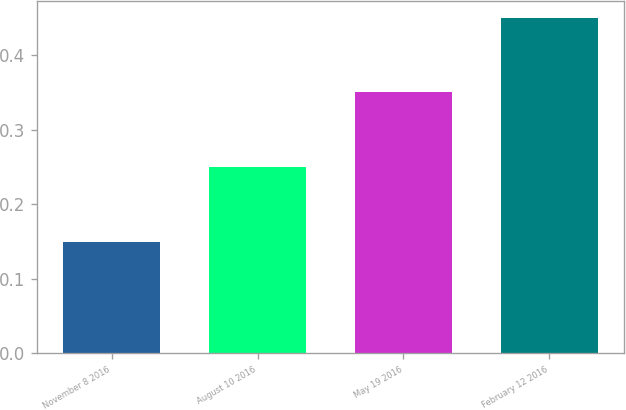<chart> <loc_0><loc_0><loc_500><loc_500><bar_chart><fcel>November 8 2016<fcel>August 10 2016<fcel>May 19 2016<fcel>February 12 2016<nl><fcel>0.15<fcel>0.25<fcel>0.35<fcel>0.45<nl></chart> 